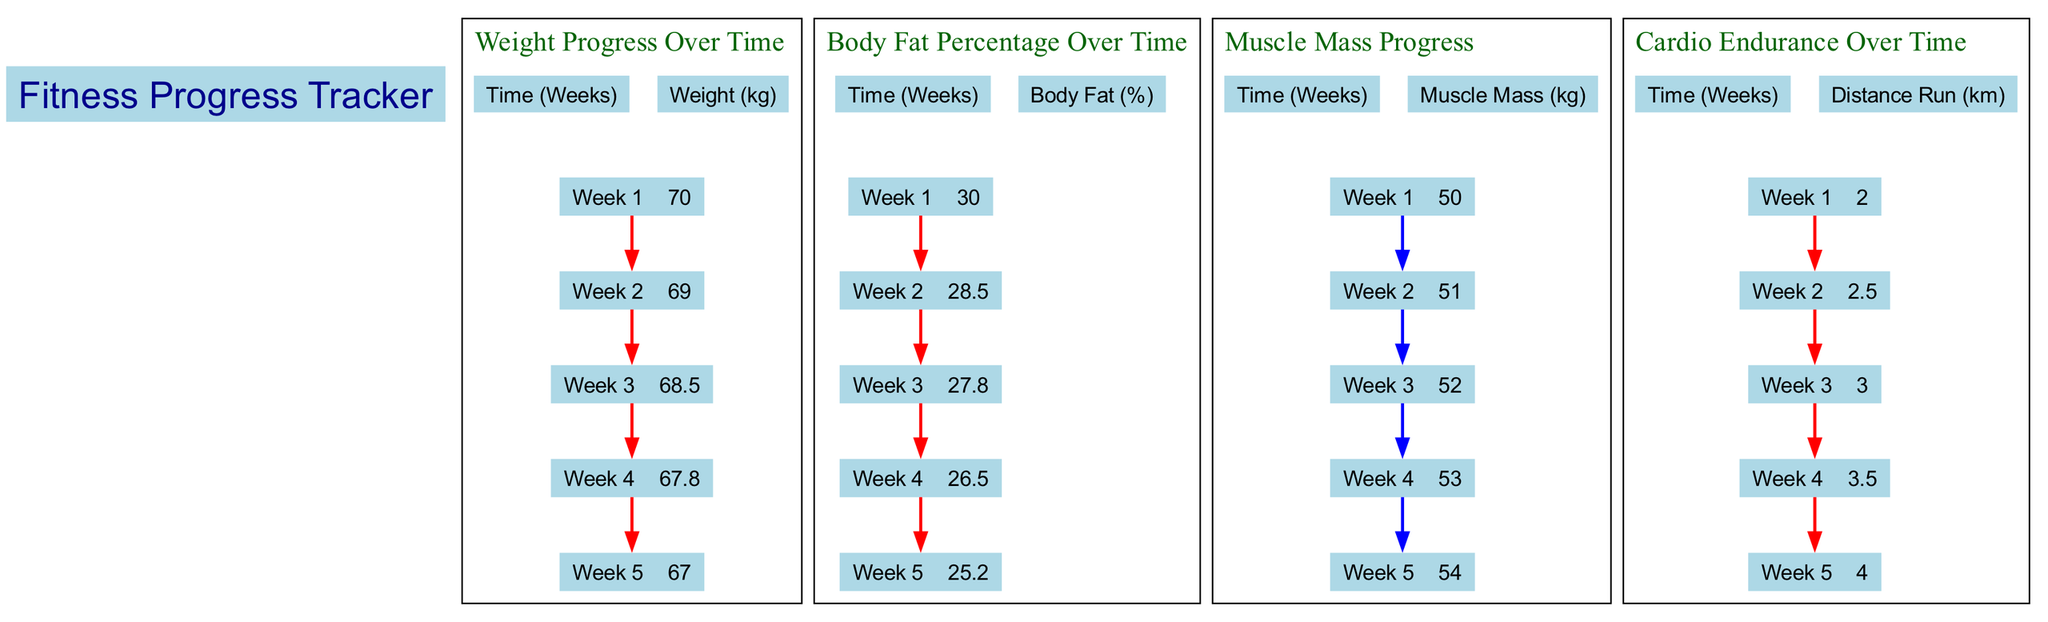What is the weight at Week 3? Looking at the "Weight Progress Over Time" chart, we find the data point for "Week 3" shows a weight of 68.5 kg.
Answer: 68.5 kg What is the body fat percentage at Week 5? In the "Body Fat Percentage Over Time" chart, the value for "Week 5" is clearly indicated as 25.2%.
Answer: 25.2% How many data points are shown for muscle mass? The "Muscle Mass Progress" bar graph includes data for each of the five weeks, thus there are a total of five data points.
Answer: 5 What was the distance run at Week 2? In the "Cardio Endurance Over Time" chart, the value corresponding to "Week 2" is listed as 2.5 km.
Answer: 2.5 km Which metric shows a steady increase over the first five weeks? Observing the "Muscle Mass Progress" bar graph, we notice that the muscle mass value consistently rises from 50 kg at Week 1 to 54 kg at Week 5.
Answer: Muscle mass What is the highest body fat percentage recorded? The chart for "Body Fat Percentage Over Time" shows the highest value at "Week 1," where it is recorded as 30%.
Answer: 30% How much weight was lost from Week 1 to Week 5? By comparing the weight at "Week 1" (70 kg) with the weight at "Week 5" (67 kg), we find the weight loss to be 3 kg over that period.
Answer: 3 kg Which week saw the greatest improvement in cardio endurance? The increase in cardio endurance from "Week 1" (2 km) to "Week 5" (4 km) demonstrates a constant improvement, with the largest single-week increase occurring from "Week 4" (3.5 km) to "Week 5" (4 km), totaling a 0.5 km increase.
Answer: 0.5 km What trend is observed in weight over the five weeks? The "Weight Progress Over Time" chart illustrates a downward trend, showing a decrease in weight from 70 kg in Week 1 to 67 kg in Week 5.
Answer: Downward trend 